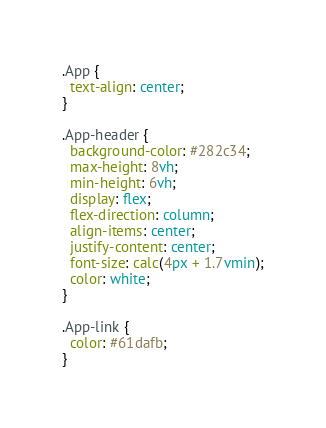Convert code to text. <code><loc_0><loc_0><loc_500><loc_500><_CSS_>.App {
  text-align: center;
}

.App-header {
  background-color: #282c34;
  max-height: 8vh;
  min-height: 6vh;
  display: flex;
  flex-direction: column;
  align-items: center;
  justify-content: center;
  font-size: calc(4px + 1.7vmin);
  color: white;
}

.App-link {
  color: #61dafb;
}
</code> 